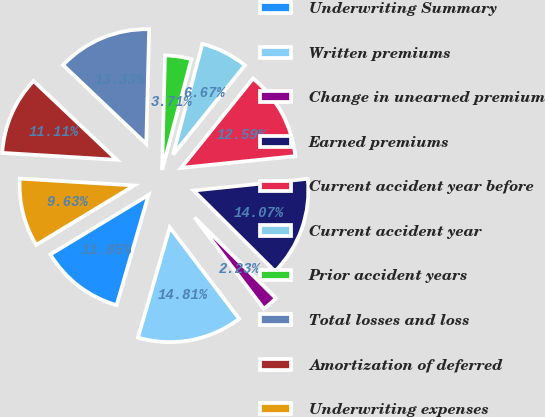Convert chart. <chart><loc_0><loc_0><loc_500><loc_500><pie_chart><fcel>Underwriting Summary<fcel>Written premiums<fcel>Change in unearned premium<fcel>Earned premiums<fcel>Current accident year before<fcel>Current accident year<fcel>Prior accident years<fcel>Total losses and loss<fcel>Amortization of deferred<fcel>Underwriting expenses<nl><fcel>11.85%<fcel>14.81%<fcel>2.23%<fcel>14.07%<fcel>12.59%<fcel>6.67%<fcel>3.71%<fcel>13.33%<fcel>11.11%<fcel>9.63%<nl></chart> 